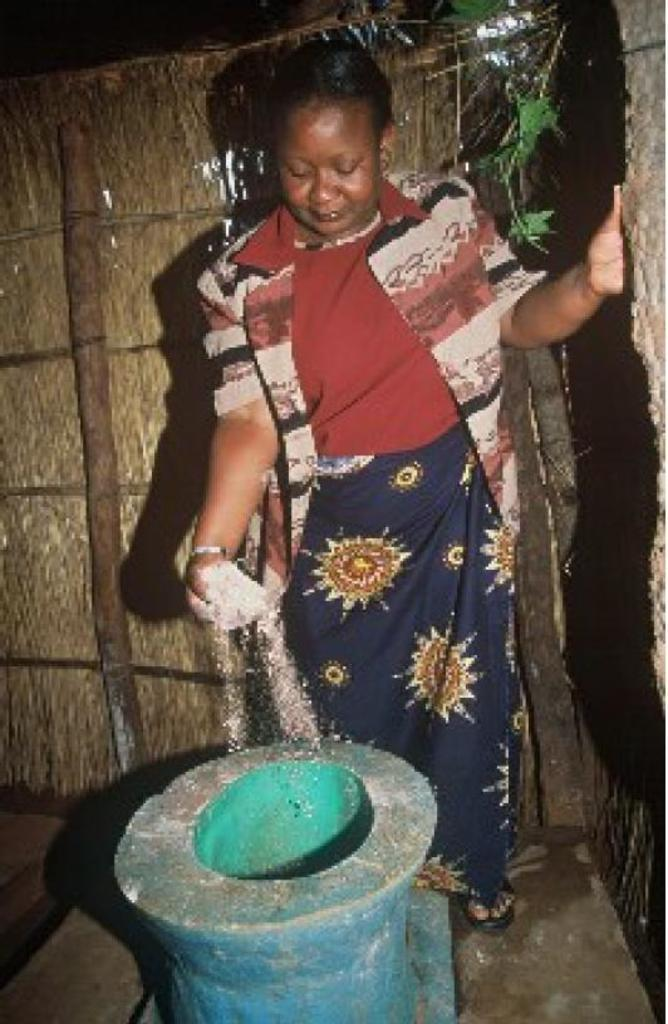Who is the main subject in the image? There is a woman in the image. What is the woman doing in the image? The woman is standing and pouring something into a stone object. What type of thunder can be heard in the image? There is no thunder present in the image, as it is a visual medium and does not convey sound. 